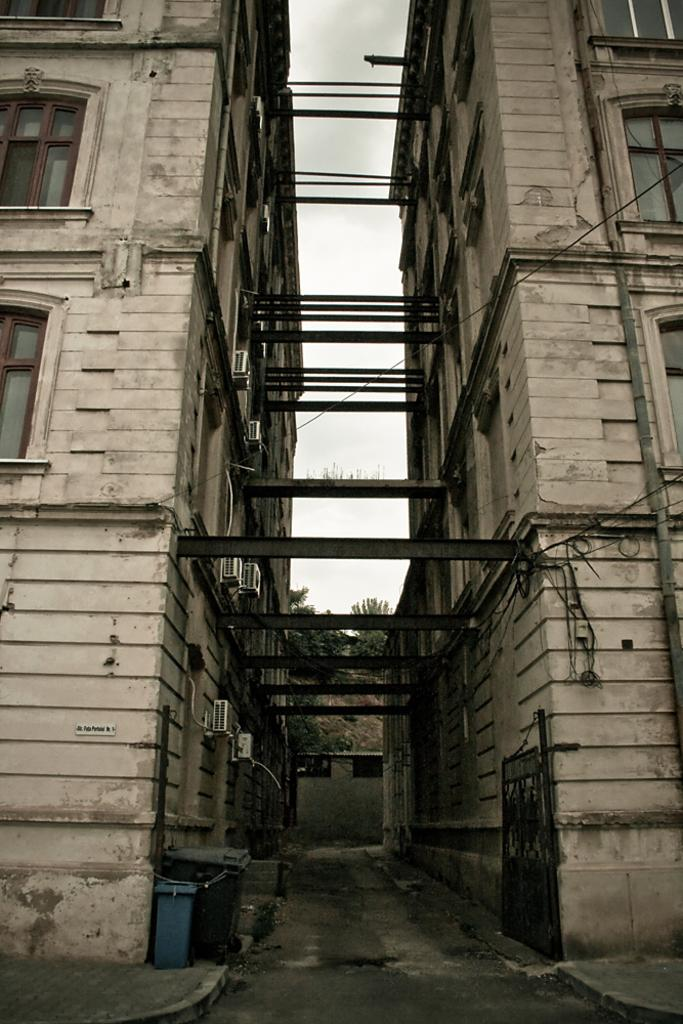What type of structures can be seen in the image? There are buildings in the image. What object is present for waste disposal? There is a dustbin in the image. What type of vegetation can be seen in the background of the image? There are trees visible in the background of the image. What is visible in the sky in the image? There are clouds in the sky, and the sky is visible in the background of the image. How many toys are scattered on the beds in the image? There are no toys or beds present in the image. 